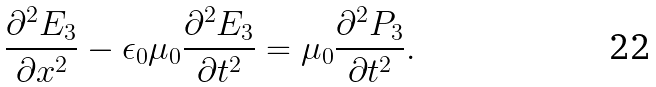<formula> <loc_0><loc_0><loc_500><loc_500>\frac { \partial ^ { 2 } E _ { 3 } } { \partial x ^ { 2 } } - \epsilon _ { 0 } \mu _ { 0 } \frac { \partial ^ { 2 } E _ { 3 } } { \partial t ^ { 2 } } = \mu _ { 0 } \frac { \partial ^ { 2 } P _ { 3 } } { \partial t ^ { 2 } } .</formula> 